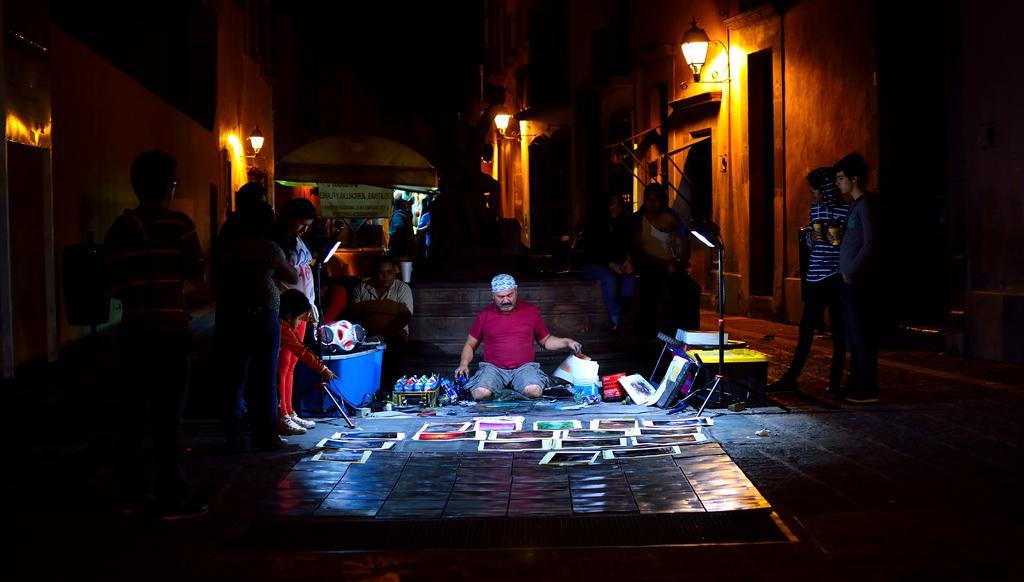Can you describe this image briefly? In the middle a man is sitting on the floor, on the left side few persons are standing and observing the things in the middle of an image. There are lights to the walls in this image. 